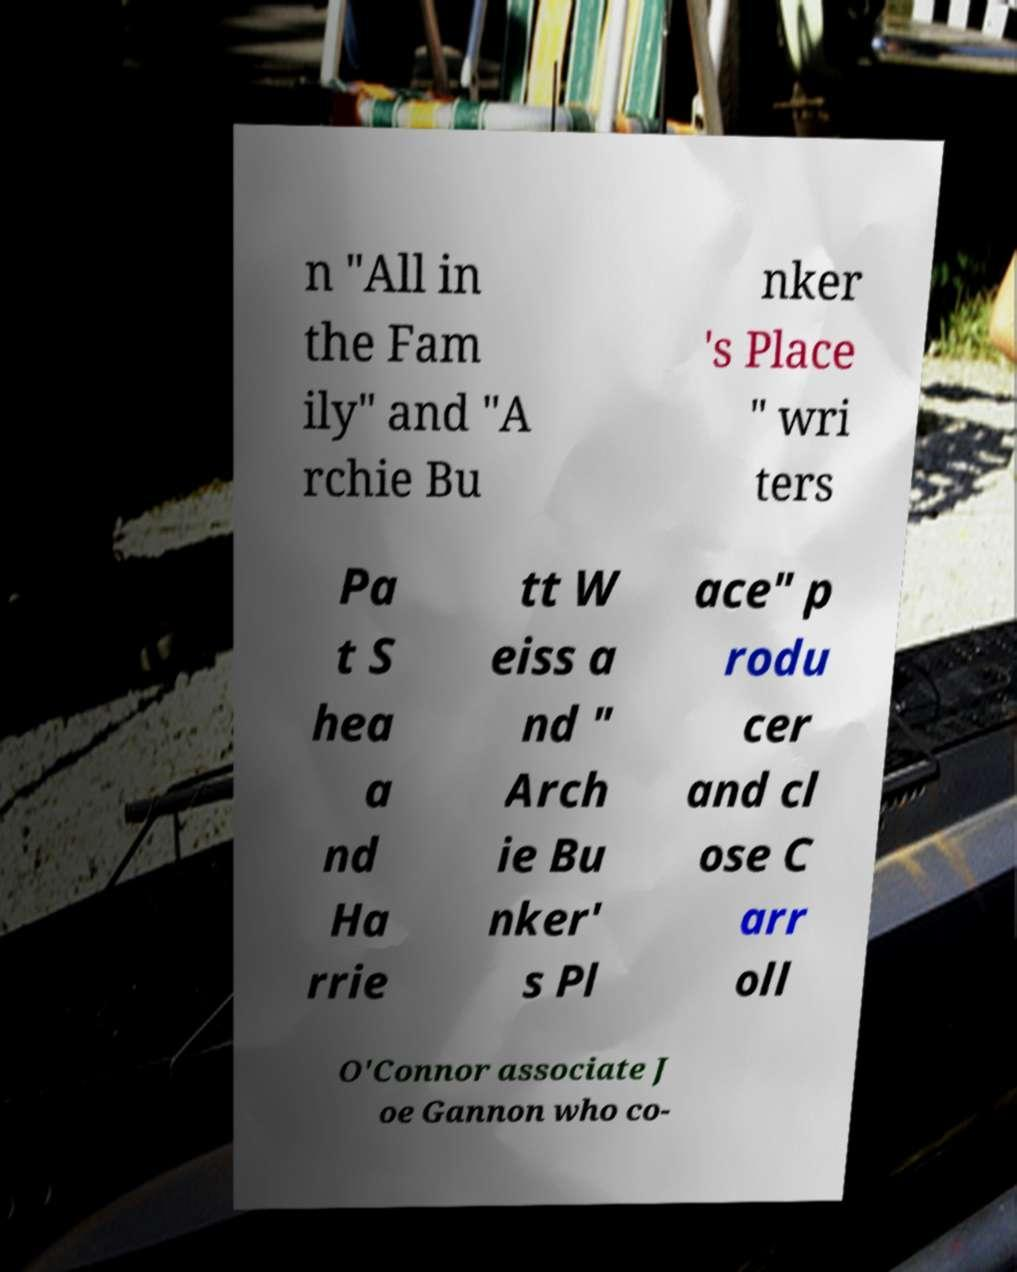Please identify and transcribe the text found in this image. n "All in the Fam ily" and "A rchie Bu nker 's Place " wri ters Pa t S hea a nd Ha rrie tt W eiss a nd " Arch ie Bu nker' s Pl ace" p rodu cer and cl ose C arr oll O'Connor associate J oe Gannon who co- 